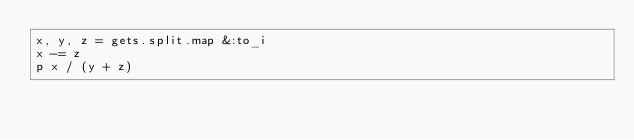Convert code to text. <code><loc_0><loc_0><loc_500><loc_500><_Ruby_>x, y, z = gets.split.map &:to_i
x -= z
p x / (y + z)</code> 